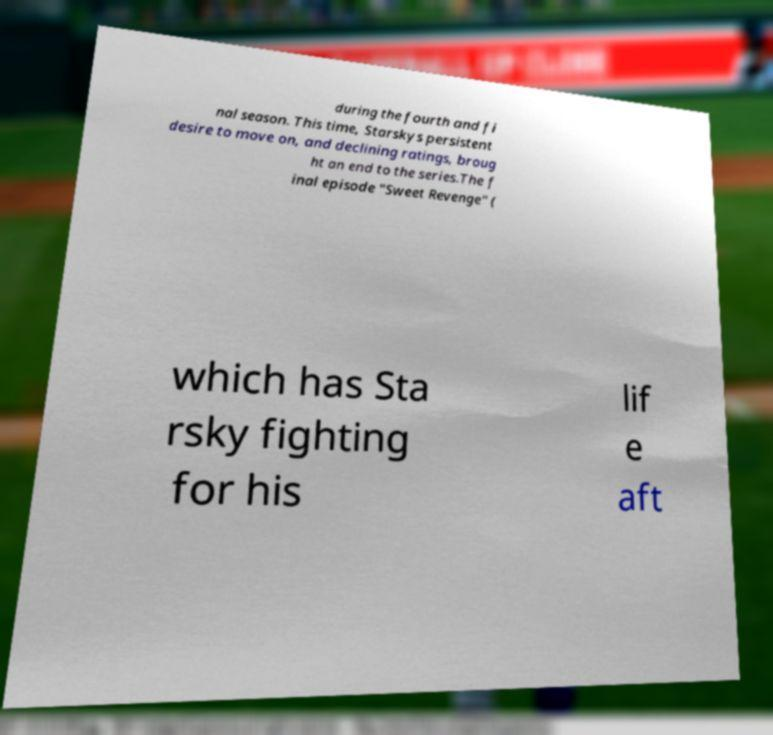Could you assist in decoding the text presented in this image and type it out clearly? during the fourth and fi nal season. This time, Starskys persistent desire to move on, and declining ratings, broug ht an end to the series.The f inal episode "Sweet Revenge" ( which has Sta rsky fighting for his lif e aft 